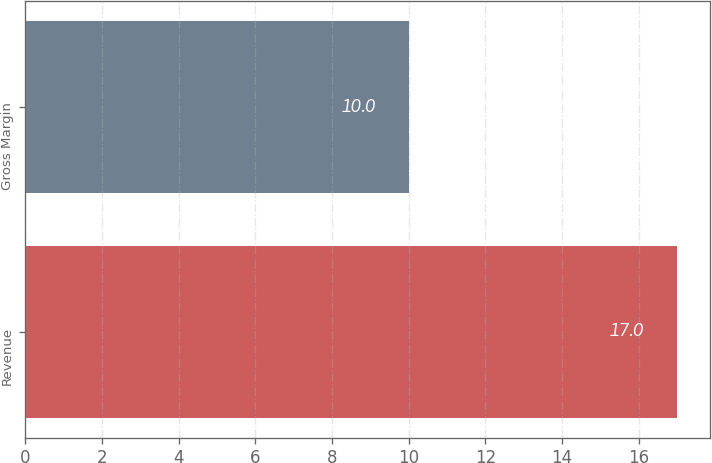Convert chart to OTSL. <chart><loc_0><loc_0><loc_500><loc_500><bar_chart><fcel>Revenue<fcel>Gross Margin<nl><fcel>17<fcel>10<nl></chart> 